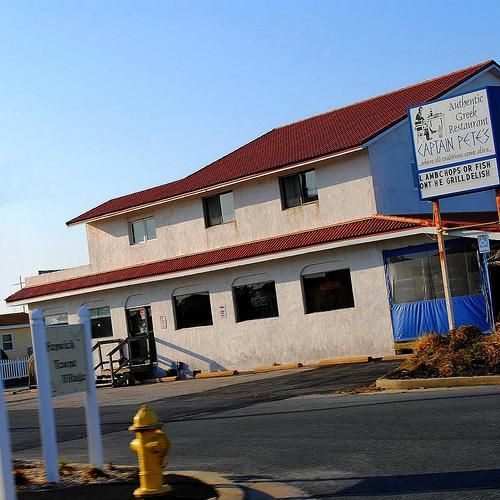Describe the colors and shapes of some objects in the picture. The image features a cylindrical yellow fire hydrant, a straight white picket fence, and a rectangular business sign with black and blue letters. List five main objects or elements found in the image. 5. White clouds in blue sky Mention a few notable elements in the image using some adjectives. A vibrant yellow fire hydrant, an elegant white picket fence, a bold red-roofed building, and a clear blue sky filled with fluffy white clouds. Mention two objects in the image and describe their position. In the image, a yellow fire hydrant is situated close to a white picket fence that lines the street. Provide a brief description of the main objects in the picture using simple language. There's a yellow fire hydrant, a white picket fence, a building with a red roof, a handicap sign, and many white clouds in the blue sky. Describe the image using a storytelling style. Once upon a time, in a little town, there was a yellow fire hydrant that stood proudly beside a lovely white picket fence, across the street from a building with a vibrant red roof and a handicap sign. The sky above them was blue and filled with cotton-like clouds. Provide a description of the image using a poetic tone. A charming scene unfolds with a quaint white fence, a bright fire hydrant in yellow hues, and a building adorned with a bold red roof, all under a vast sky of heavenly blue. Write a brief description of the image using a journalistic style. In the picturesque scene captures a corner featuring a typical urban red-roofed building, a yellow fire hydrant, a white picket fence, and a handicap sign, all beneath a sunny sky with scattered white clouds. Express the main features of the image in the form of an advertising slogan. "Experience a picture-perfect town with charming sights: from the radiant red-roofed buildings, delightful white picket fences, to the cheerful yellow fire hydrants and endless blue skies!" Write a short sentence describing three elements in the image. A building with a red roof stands near a yellow fire hydrant and a white picket fence in front of a sky with white clouds. 